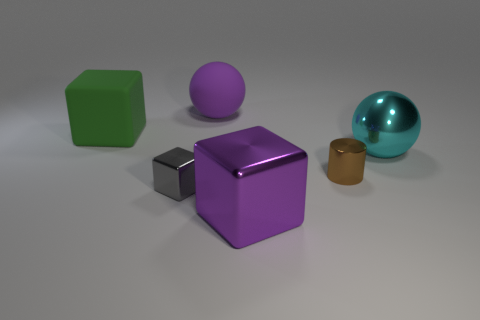Is there a shiny object of the same size as the brown metallic cylinder? Yes, the shiny turquoise sphere is approximately the same size as the brown metallic cylinder. Both objects display similar dimensions, contributing to a visual symmetry in the scene. 